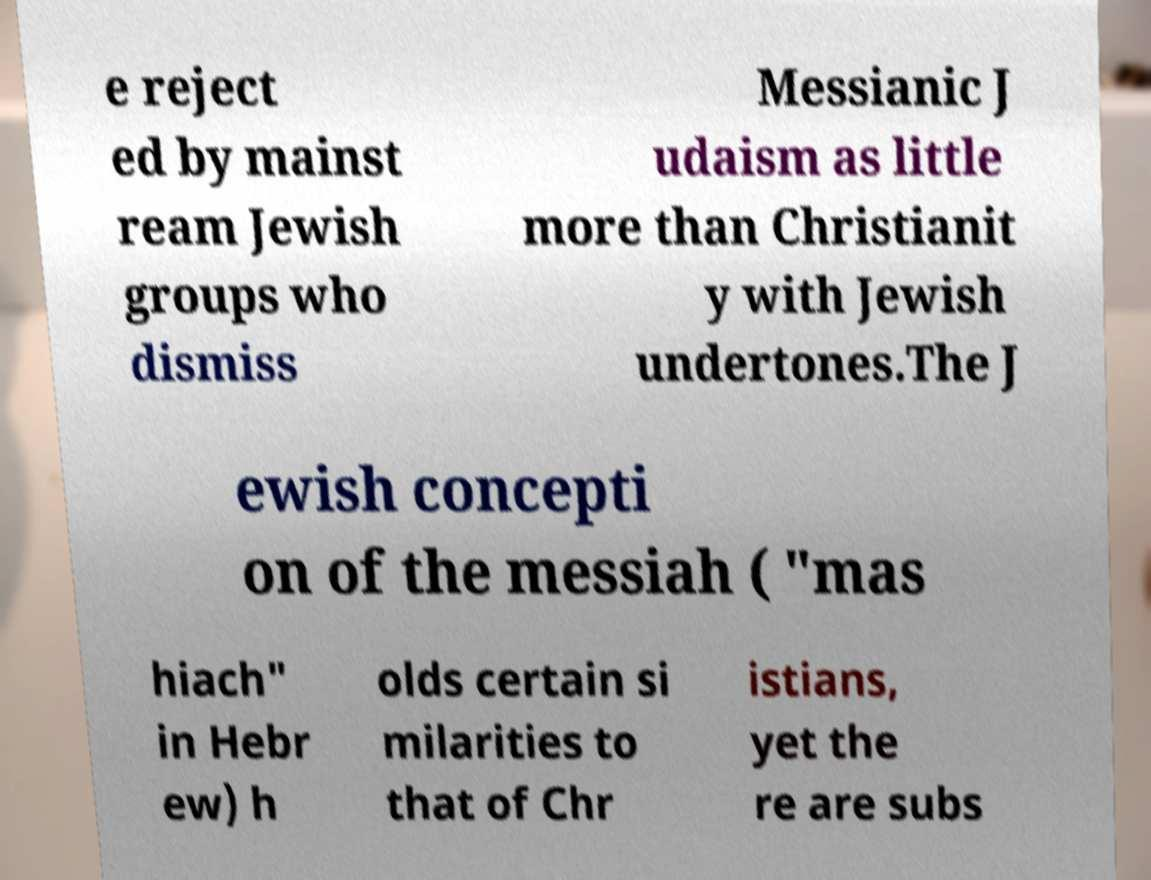Can you read and provide the text displayed in the image?This photo seems to have some interesting text. Can you extract and type it out for me? e reject ed by mainst ream Jewish groups who dismiss Messianic J udaism as little more than Christianit y with Jewish undertones.The J ewish concepti on of the messiah ( "mas hiach" in Hebr ew) h olds certain si milarities to that of Chr istians, yet the re are subs 